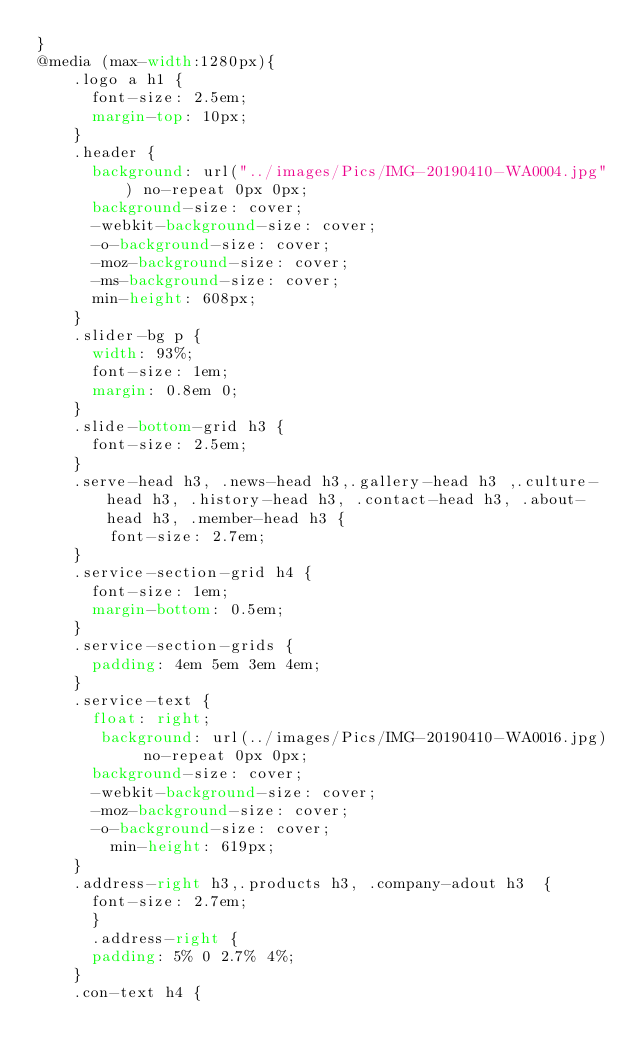Convert code to text. <code><loc_0><loc_0><loc_500><loc_500><_CSS_>}
@media (max-width:1280px){
	.logo a h1 {
	  font-size: 2.5em;
	  margin-top: 10px;
	}
	.header {
	  background: url("../images/Pics/IMG-20190410-WA0004.jpg") no-repeat 0px 0px;
	  background-size: cover;
	  -webkit-background-size: cover;
	  -o-background-size: cover;
	  -moz-background-size: cover;
	  -ms-background-size: cover;
	  min-height: 608px;
	}
	.slider-bg p {
	  width: 93%;
	  font-size: 1em;
	  margin: 0.8em 0;
	}
	.slide-bottom-grid h3 {
	  font-size: 2.5em;
	}
	.serve-head h3, .news-head h3,.gallery-head h3 ,.culture-head h3, .history-head h3, .contact-head h3, .about-head h3, .member-head h3 {
	    font-size: 2.7em;
	}
	.service-section-grid h4 {
	  font-size: 1em;
	  margin-bottom: 0.5em;
	}
	.service-section-grids {
	  padding: 4em 5em 3em 4em;
	}
	.service-text {
	  float: right;
	   background: url(../images/Pics/IMG-20190410-WA0016.jpg) no-repeat 0px 0px;
	  background-size: cover;
	  -webkit-background-size: cover;
	  -moz-background-size: cover;
	  -o-background-size: cover;
	    min-height: 619px;
	}
	.address-right h3,.products h3, .company-adout h3  {
	  font-size: 2.7em;
	  }
	  .address-right {
	  padding: 5% 0 2.7% 4%;
	}
	.con-text h4 {</code> 